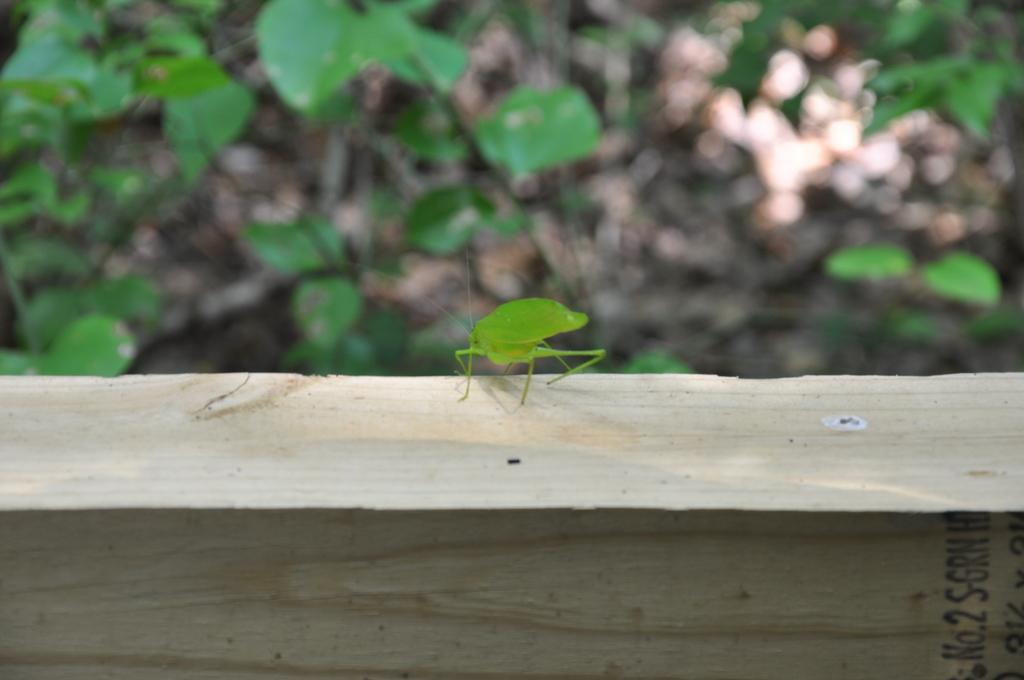What type of insect is in the image? There is a stink bug insect in the image. Where is the insect located? The insect is on a wooden block. What other elements can be seen in the image? There are green leaves in the image. How does the insect use the lock to copy the knife in the image? There is no lock or knife present in the image, and the insect does not engage in any copying behavior. 